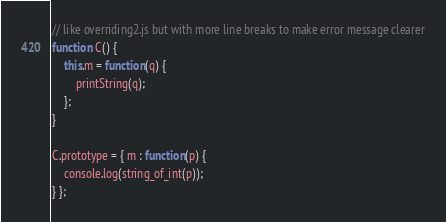Convert code to text. <code><loc_0><loc_0><loc_500><loc_500><_JavaScript_>// like overriding2.js but with more line breaks to make error message clearer
function C() {
    this.m = function(q) { 
    	printString(q); 
    };
}

C.prototype = { m : function(p) { 
	console.log(string_of_int(p)); 
} };
</code> 